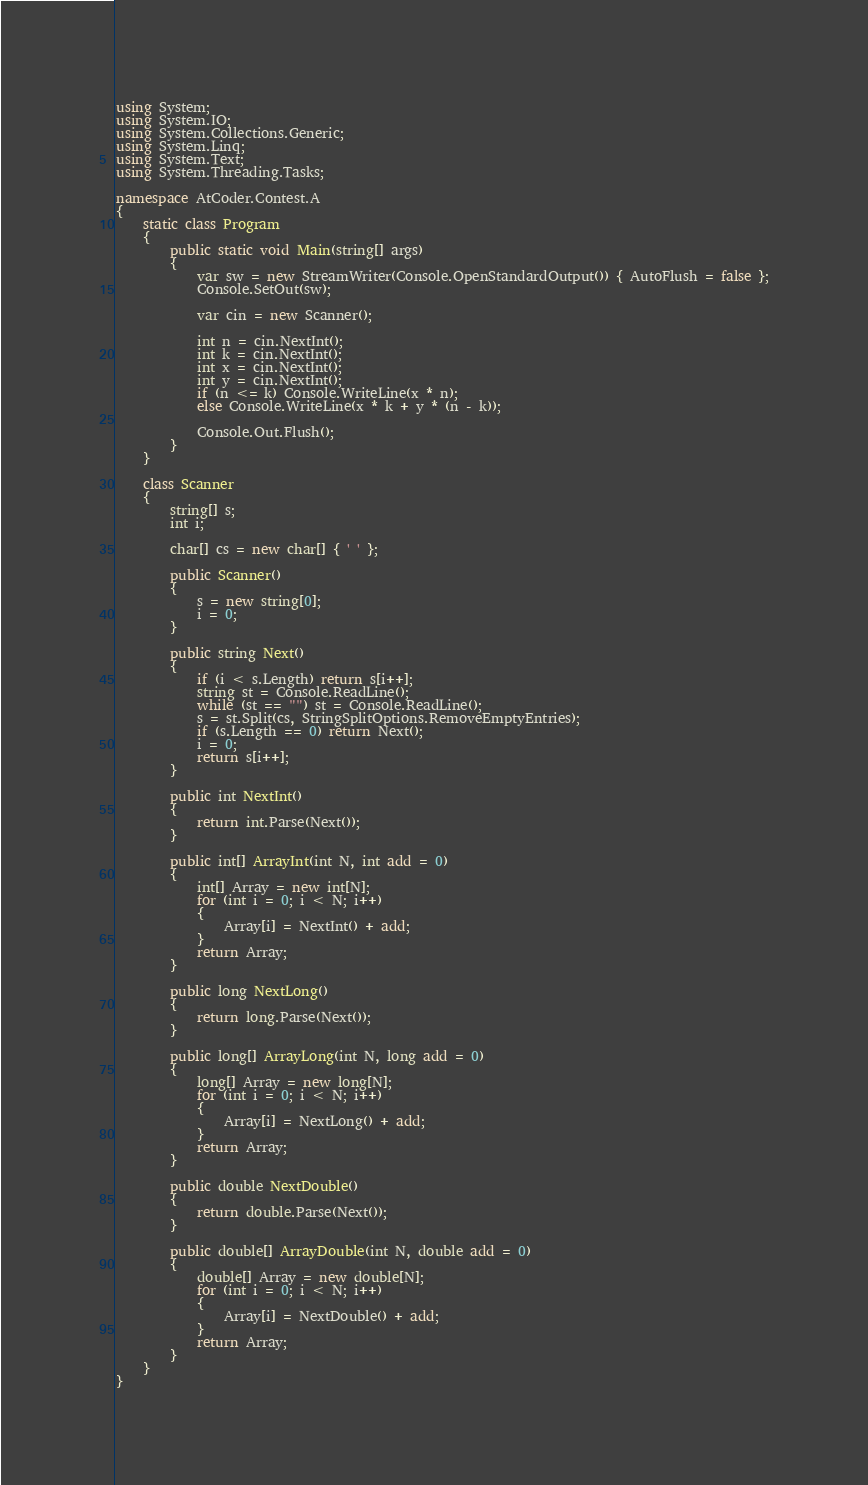<code> <loc_0><loc_0><loc_500><loc_500><_C#_>using System;
using System.IO;
using System.Collections.Generic;
using System.Linq;
using System.Text;
using System.Threading.Tasks;

namespace AtCoder.Contest.A
{
	static class Program
	{
		public static void Main(string[] args)
		{
			var sw = new StreamWriter(Console.OpenStandardOutput()) { AutoFlush = false };
			Console.SetOut(sw);

			var cin = new Scanner();

			int n = cin.NextInt();
			int k = cin.NextInt();
			int x = cin.NextInt();
			int y = cin.NextInt();
			if (n <= k) Console.WriteLine(x * n);
			else Console.WriteLine(x * k + y * (n - k));

			Console.Out.Flush();
		}
	}

	class Scanner
	{
		string[] s;
		int i;

		char[] cs = new char[] { ' ' };

		public Scanner()
		{
			s = new string[0];
			i = 0;
		}

		public string Next()
		{
			if (i < s.Length) return s[i++];
			string st = Console.ReadLine();
			while (st == "") st = Console.ReadLine();
			s = st.Split(cs, StringSplitOptions.RemoveEmptyEntries);
			if (s.Length == 0) return Next();
			i = 0;
			return s[i++];
		}

		public int NextInt()
		{
			return int.Parse(Next());
		}

		public int[] ArrayInt(int N, int add = 0)
		{
			int[] Array = new int[N];
			for (int i = 0; i < N; i++)
			{
				Array[i] = NextInt() + add;
			}
			return Array;
		}

		public long NextLong()
		{
			return long.Parse(Next());
		}

		public long[] ArrayLong(int N, long add = 0)
		{
			long[] Array = new long[N];
			for (int i = 0; i < N; i++)
			{
				Array[i] = NextLong() + add;
			}
			return Array;
		}

		public double NextDouble()
		{
			return double.Parse(Next());
		}

		public double[] ArrayDouble(int N, double add = 0)
		{
			double[] Array = new double[N];
			for (int i = 0; i < N; i++)
			{
				Array[i] = NextDouble() + add;
			}
			return Array;
		}
	}
}</code> 